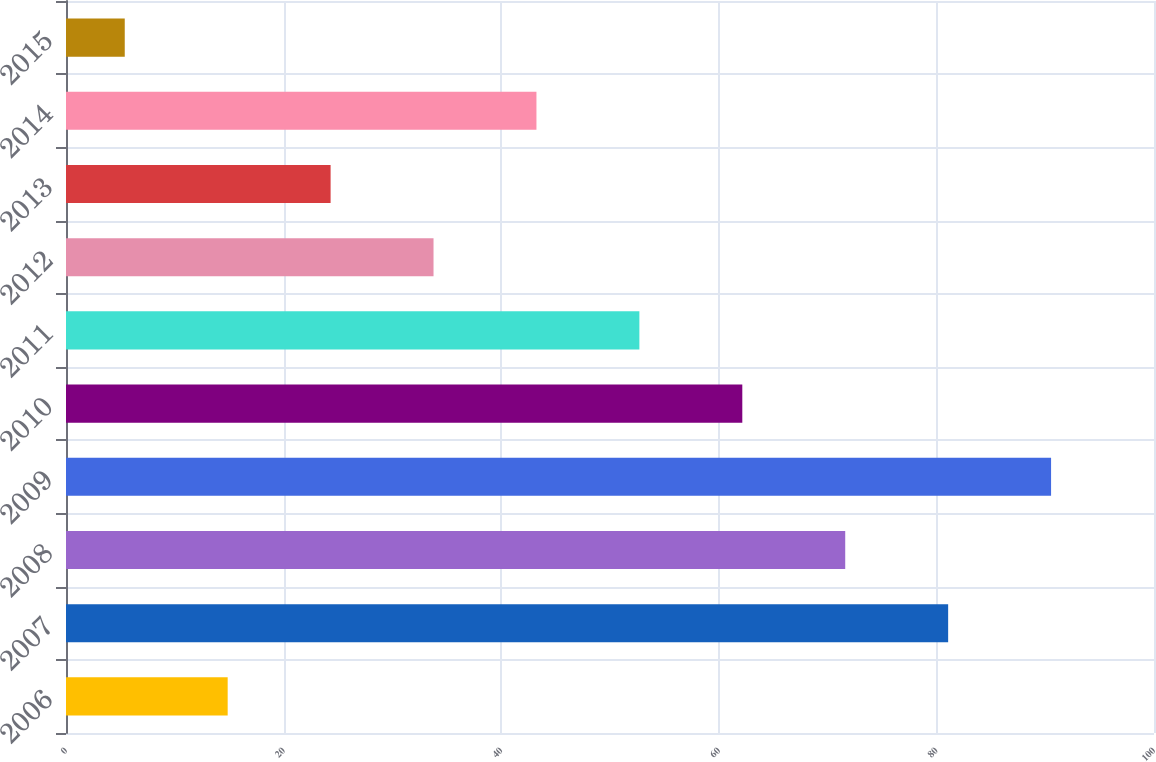Convert chart. <chart><loc_0><loc_0><loc_500><loc_500><bar_chart><fcel>2006<fcel>2007<fcel>2008<fcel>2009<fcel>2010<fcel>2011<fcel>2012<fcel>2013<fcel>2014<fcel>2015<nl><fcel>14.86<fcel>81.08<fcel>71.62<fcel>90.54<fcel>62.16<fcel>52.7<fcel>33.78<fcel>24.32<fcel>43.24<fcel>5.4<nl></chart> 